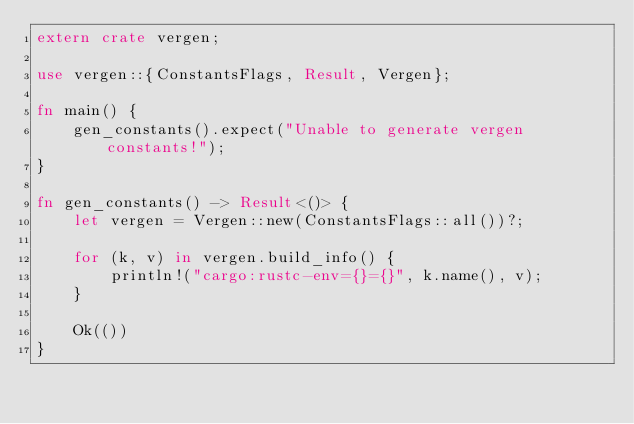Convert code to text. <code><loc_0><loc_0><loc_500><loc_500><_Rust_>extern crate vergen;

use vergen::{ConstantsFlags, Result, Vergen};

fn main() {
    gen_constants().expect("Unable to generate vergen constants!");
}

fn gen_constants() -> Result<()> {
    let vergen = Vergen::new(ConstantsFlags::all())?;

    for (k, v) in vergen.build_info() {
        println!("cargo:rustc-env={}={}", k.name(), v);
    }

    Ok(())
}
</code> 